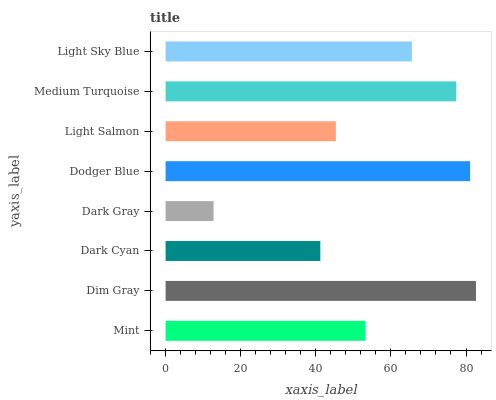Is Dark Gray the minimum?
Answer yes or no. Yes. Is Dim Gray the maximum?
Answer yes or no. Yes. Is Dark Cyan the minimum?
Answer yes or no. No. Is Dark Cyan the maximum?
Answer yes or no. No. Is Dim Gray greater than Dark Cyan?
Answer yes or no. Yes. Is Dark Cyan less than Dim Gray?
Answer yes or no. Yes. Is Dark Cyan greater than Dim Gray?
Answer yes or no. No. Is Dim Gray less than Dark Cyan?
Answer yes or no. No. Is Light Sky Blue the high median?
Answer yes or no. Yes. Is Mint the low median?
Answer yes or no. Yes. Is Dark Cyan the high median?
Answer yes or no. No. Is Dark Gray the low median?
Answer yes or no. No. 